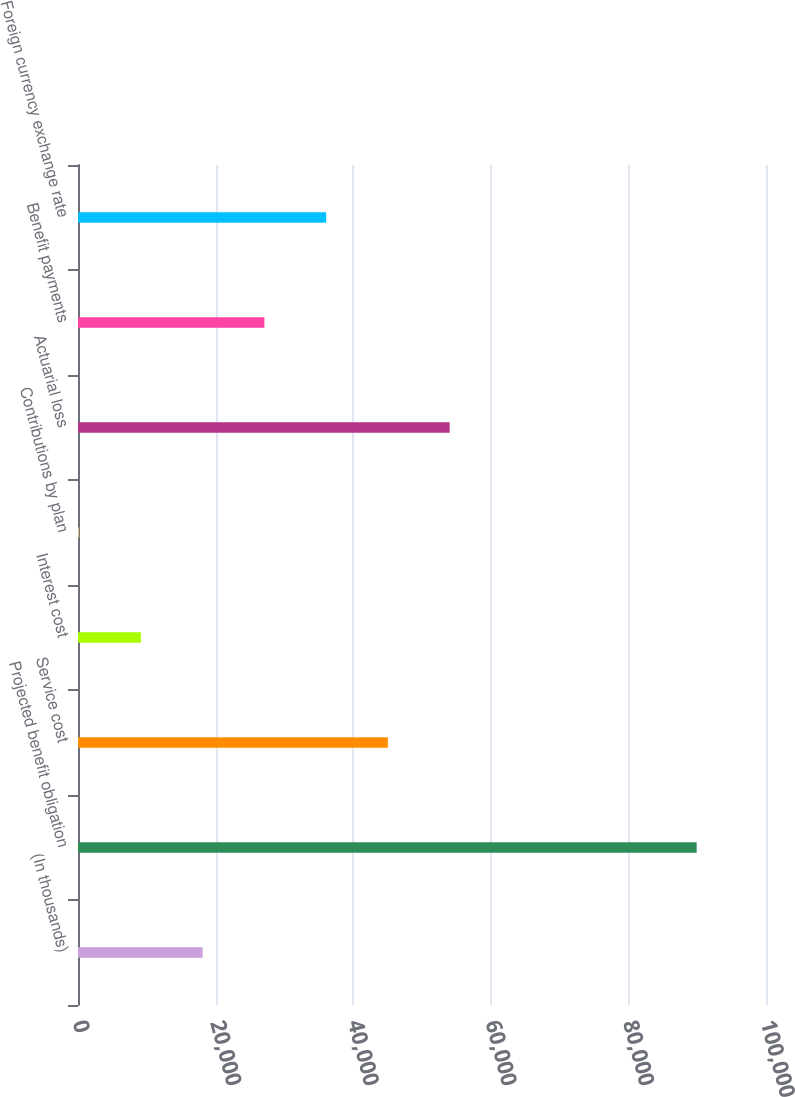Convert chart. <chart><loc_0><loc_0><loc_500><loc_500><bar_chart><fcel>(In thousands)<fcel>Projected benefit obligation<fcel>Service cost<fcel>Interest cost<fcel>Contributions by plan<fcel>Actuarial loss<fcel>Benefit payments<fcel>Foreign currency exchange rate<nl><fcel>18115<fcel>89923<fcel>45043<fcel>9139<fcel>163<fcel>54019<fcel>27091<fcel>36067<nl></chart> 